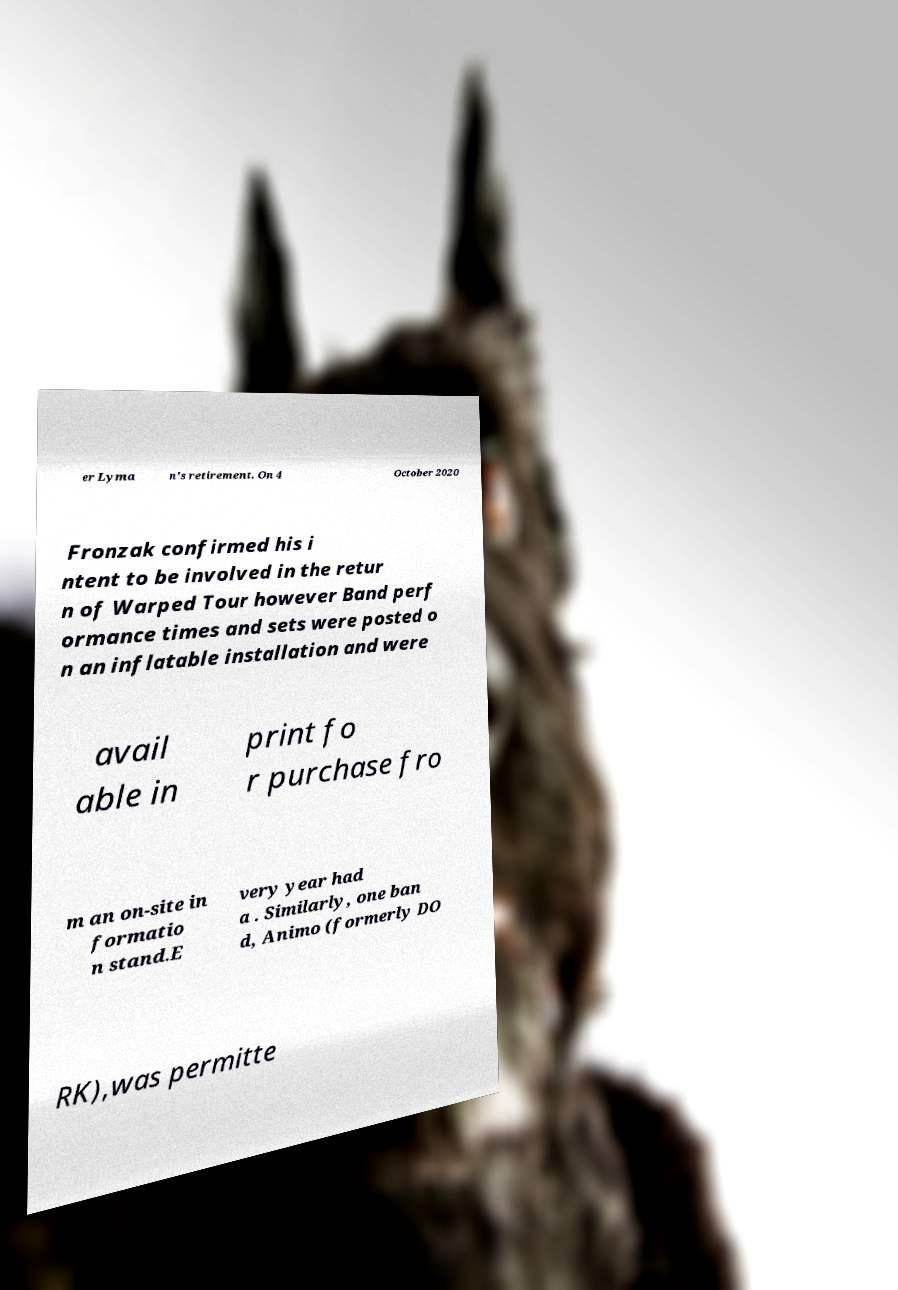Could you assist in decoding the text presented in this image and type it out clearly? er Lyma n's retirement. On 4 October 2020 Fronzak confirmed his i ntent to be involved in the retur n of Warped Tour however Band perf ormance times and sets were posted o n an inflatable installation and were avail able in print fo r purchase fro m an on-site in formatio n stand.E very year had a . Similarly, one ban d, Animo (formerly DO RK),was permitte 